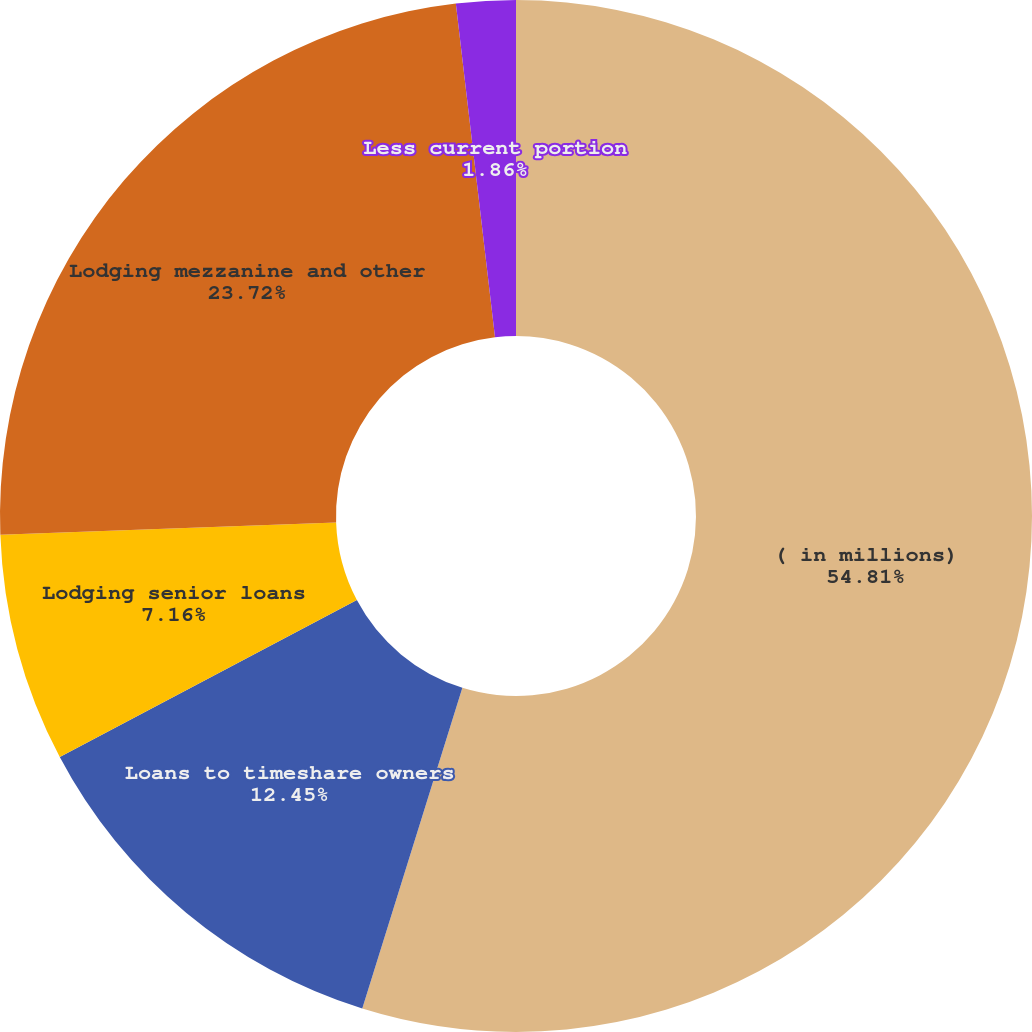<chart> <loc_0><loc_0><loc_500><loc_500><pie_chart><fcel>( in millions)<fcel>Loans to timeshare owners<fcel>Lodging senior loans<fcel>Lodging mezzanine and other<fcel>Less current portion<nl><fcel>54.82%<fcel>12.45%<fcel>7.16%<fcel>23.72%<fcel>1.86%<nl></chart> 